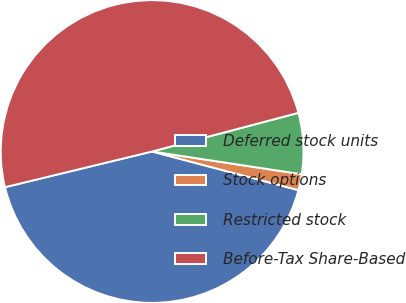<chart> <loc_0><loc_0><loc_500><loc_500><pie_chart><fcel>Deferred stock units<fcel>Stock options<fcel>Restricted stock<fcel>Before-Tax Share-Based<nl><fcel>42.11%<fcel>1.71%<fcel>6.51%<fcel>49.68%<nl></chart> 